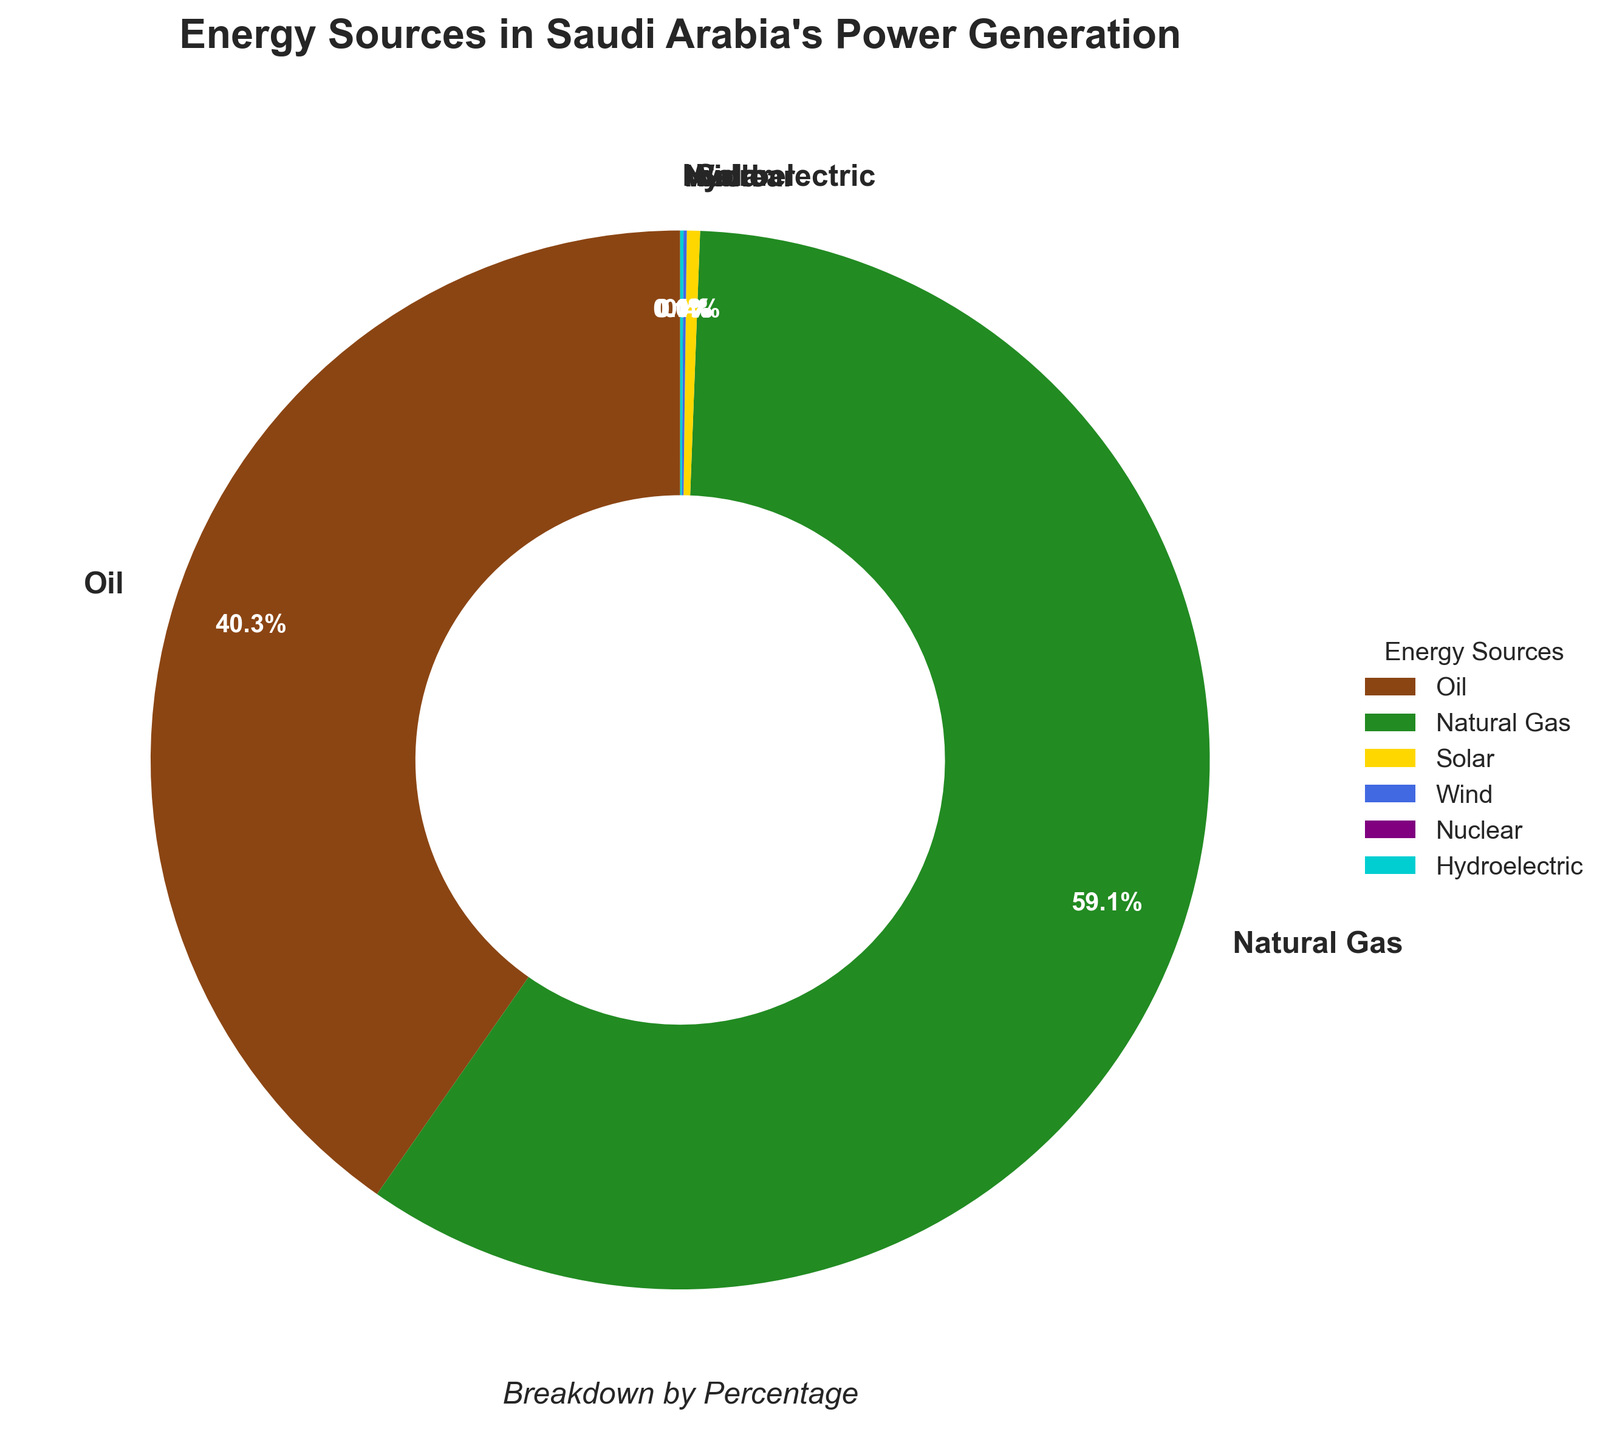What is the most abundant energy source in Saudi Arabia's power generation? The figure shows that Natural Gas has the largest percentage compared to other sources.
Answer: Natural Gas Which energy source contributes the least to Saudi Arabia's power generation? By looking at the smallest percentage in the pie chart, we see that Nuclear contributes 0.0%, which is the least.
Answer: Nuclear What percentage of power generation comes from renewable energy sources (Solar, Wind, and Hydroelectric combined)? Summing the percentages of Solar (0.4%), Wind (0.1%), and Hydroelectric (0.1%) gives: 0.4% + 0.1% + 0.1% = 0.6%.
Answer: 0.6% How much more percentage does Oil contribute to power generation compared to Solar? Subtracting the percentage of Solar (0.4%) from Oil (40.3%) gives: 40.3% - 0.4% = 39.9%.
Answer: 39.9% Which energy sources together make up more than 99% of the power generation in Saudi Arabia? Adding the percentages of Oil (40.3%) and Natural Gas (59.1%) gives: 40.3% + 59.1% = 99.4%, which is more than 99%.
Answer: Oil and Natural Gas What is the ratio of Natural Gas to Oil in terms of their contribution to power generation? The percentage of Natural Gas is 59.1% and Oil is 40.3%. The ratio is found by dividing these values: 59.1 / 40.3 ≈ 1.47.
Answer: Approximately 1.47 What color represents Solar energy in the pie chart? By identifying the color legend and corresponding segment in the pie chart, Solar energy is shown in yellow.
Answer: Yellow How does the contribution of Wind compare to Hydroelectric power? Both Wind and Hydroelectric power contribute equally at 0.1% each.
Answer: They are equal Is the combined percentage of Oil and Solar less than 50%? Adding percentages of Oil (40.3%) and Solar (0.4%) gives: 40.3% + 0.4% = 40.7%, which is less than 50%.
Answer: Yes What percentage of Saudi Arabia's power generation comes from non-renewable sources? Summing the percentages of non-renewable sources (Oil 40.3% + Natural Gas 59.1%): 40.3% + 59.1% = 99.4%.
Answer: 99.4% 